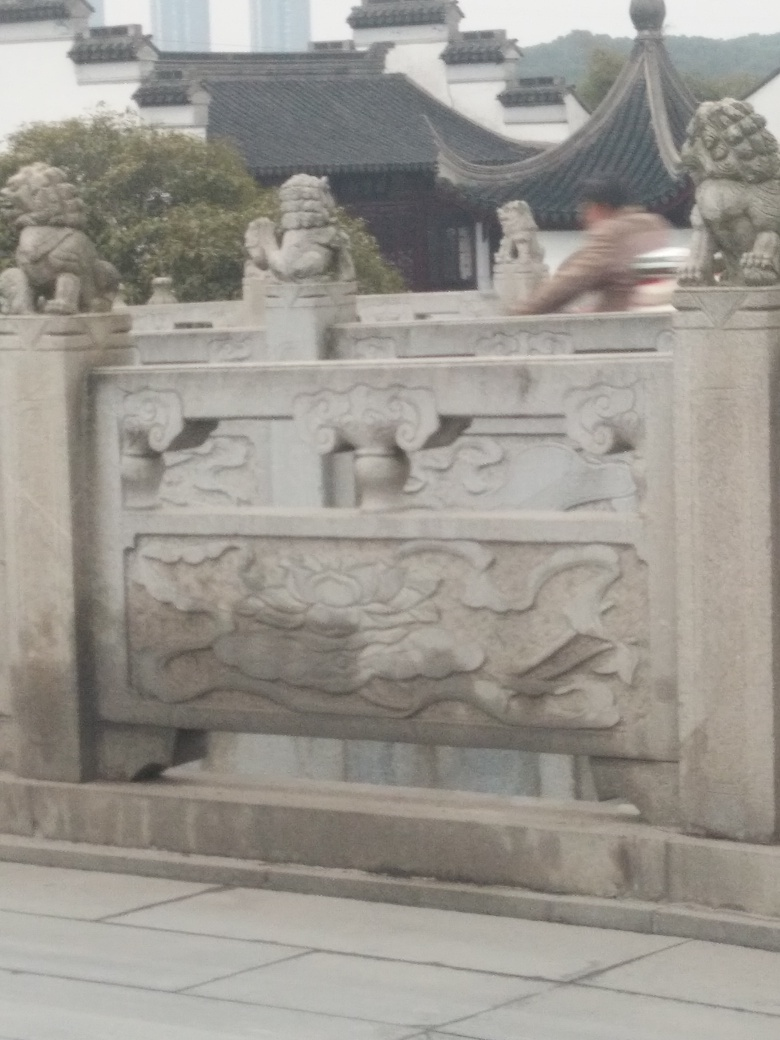What does the inclusion of the stone lions signify in this image? The stone lions in the image are traditional protective figures in Chinese architecture known as 'Shi Lions' or 'Foo Dogs.' They are believed to have guardianship qualities, often placed at entrances to repel negative energy and to attract good fortune. Their presence in this setting suggests a space of cultural or historical importance, possibly safeguarding the threshold of a temple, garden, or public building. Is there any significance to their distinct poses or designs? Each lion typically has a distinct pose and design, with one often appearing with a paw on a carved ball, representing supremacy over the world, and the other with a cub, symbolizing the nurturing nature of the species. The detailing and expressions carved into each lion can also convey a sense of power, vigilance, and elegance, contributing to their mystique and cultural symbolism. 